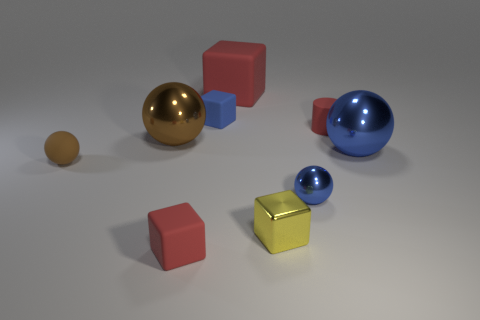Add 1 shiny objects. How many objects exist? 10 Subtract all brown spheres. How many spheres are left? 2 Subtract all blue blocks. How many blocks are left? 3 Subtract all big gray rubber spheres. Subtract all blue shiny balls. How many objects are left? 7 Add 3 red cylinders. How many red cylinders are left? 4 Add 7 cylinders. How many cylinders exist? 8 Subtract 0 purple blocks. How many objects are left? 9 Subtract all cylinders. How many objects are left? 8 Subtract 1 spheres. How many spheres are left? 3 Subtract all yellow cubes. Subtract all gray cylinders. How many cubes are left? 3 